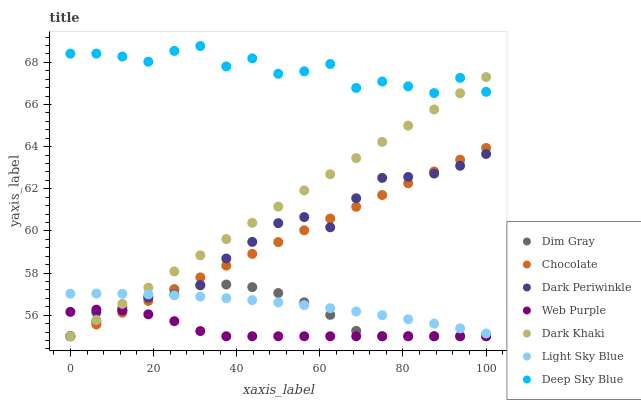Does Web Purple have the minimum area under the curve?
Answer yes or no. Yes. Does Deep Sky Blue have the maximum area under the curve?
Answer yes or no. Yes. Does Chocolate have the minimum area under the curve?
Answer yes or no. No. Does Chocolate have the maximum area under the curve?
Answer yes or no. No. Is Chocolate the smoothest?
Answer yes or no. Yes. Is Deep Sky Blue the roughest?
Answer yes or no. Yes. Is Dark Khaki the smoothest?
Answer yes or no. No. Is Dark Khaki the roughest?
Answer yes or no. No. Does Dim Gray have the lowest value?
Answer yes or no. Yes. Does Light Sky Blue have the lowest value?
Answer yes or no. No. Does Deep Sky Blue have the highest value?
Answer yes or no. Yes. Does Chocolate have the highest value?
Answer yes or no. No. Is Web Purple less than Light Sky Blue?
Answer yes or no. Yes. Is Deep Sky Blue greater than Chocolate?
Answer yes or no. Yes. Does Dark Periwinkle intersect Chocolate?
Answer yes or no. Yes. Is Dark Periwinkle less than Chocolate?
Answer yes or no. No. Is Dark Periwinkle greater than Chocolate?
Answer yes or no. No. Does Web Purple intersect Light Sky Blue?
Answer yes or no. No. 